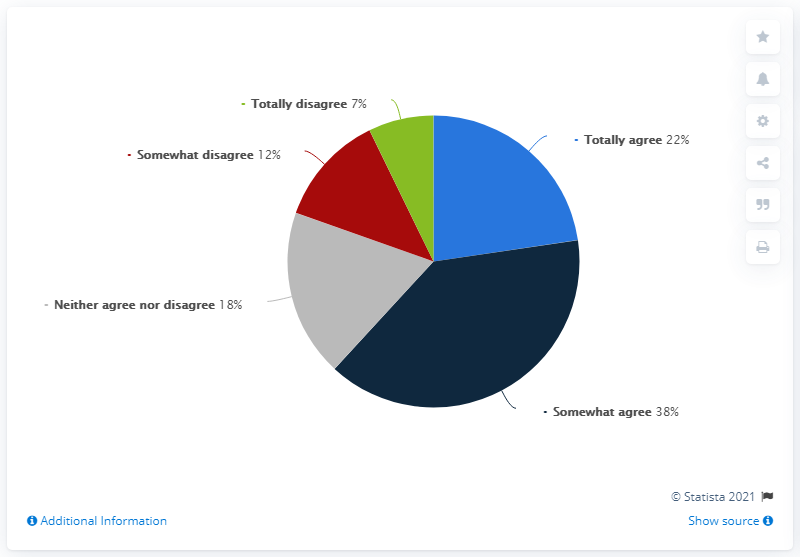Can you tell me what percentage of respondents did not agree with the statement? Combining the percentages of respondents who 'totally disagree' at 7% and 'somewhat disagree' at 12%, we find that 19% of respondents did not agree with the statement. 